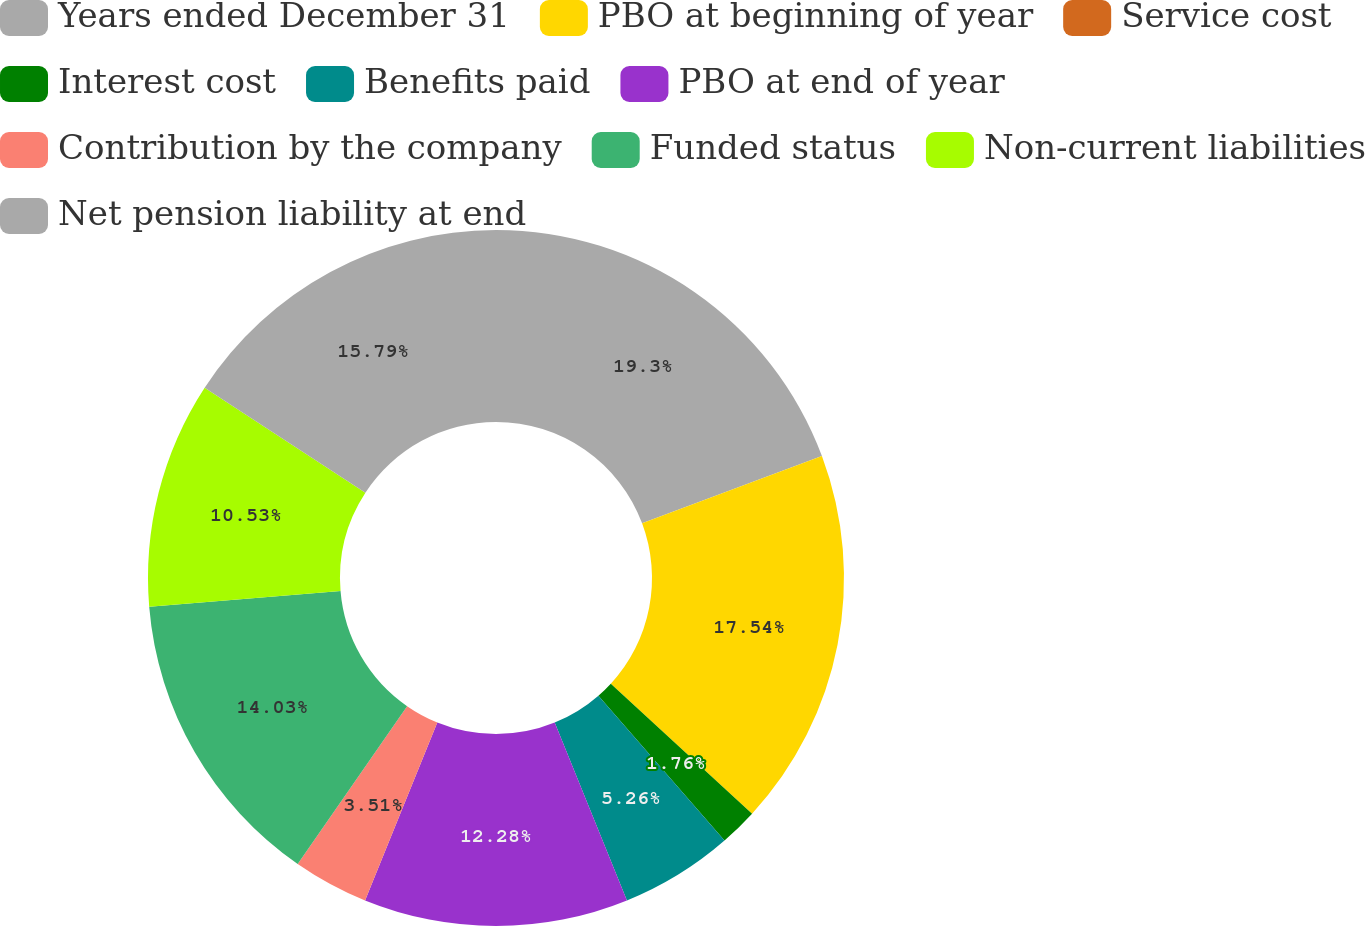Convert chart to OTSL. <chart><loc_0><loc_0><loc_500><loc_500><pie_chart><fcel>Years ended December 31<fcel>PBO at beginning of year<fcel>Service cost<fcel>Interest cost<fcel>Benefits paid<fcel>PBO at end of year<fcel>Contribution by the company<fcel>Funded status<fcel>Non-current liabilities<fcel>Net pension liability at end<nl><fcel>19.3%<fcel>17.54%<fcel>0.0%<fcel>1.76%<fcel>5.26%<fcel>12.28%<fcel>3.51%<fcel>14.03%<fcel>10.53%<fcel>15.79%<nl></chart> 